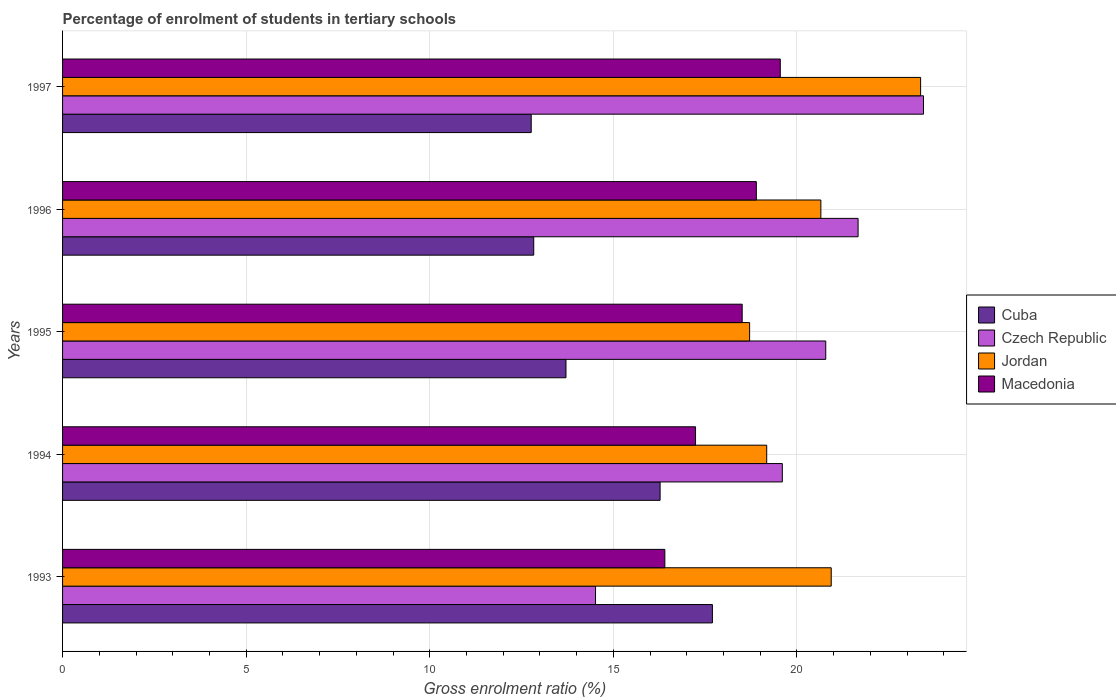How many different coloured bars are there?
Ensure brevity in your answer.  4. How many bars are there on the 1st tick from the top?
Provide a succinct answer. 4. How many bars are there on the 1st tick from the bottom?
Your answer should be very brief. 4. What is the percentage of students enrolled in tertiary schools in Cuba in 1995?
Keep it short and to the point. 13.71. Across all years, what is the maximum percentage of students enrolled in tertiary schools in Czech Republic?
Offer a very short reply. 23.45. Across all years, what is the minimum percentage of students enrolled in tertiary schools in Macedonia?
Give a very brief answer. 16.4. In which year was the percentage of students enrolled in tertiary schools in Czech Republic maximum?
Provide a short and direct response. 1997. What is the total percentage of students enrolled in tertiary schools in Cuba in the graph?
Keep it short and to the point. 73.28. What is the difference between the percentage of students enrolled in tertiary schools in Czech Republic in 1993 and that in 1995?
Provide a succinct answer. -6.27. What is the difference between the percentage of students enrolled in tertiary schools in Czech Republic in 1996 and the percentage of students enrolled in tertiary schools in Jordan in 1997?
Provide a succinct answer. -1.7. What is the average percentage of students enrolled in tertiary schools in Czech Republic per year?
Keep it short and to the point. 20. In the year 1995, what is the difference between the percentage of students enrolled in tertiary schools in Cuba and percentage of students enrolled in tertiary schools in Czech Republic?
Keep it short and to the point. -7.07. In how many years, is the percentage of students enrolled in tertiary schools in Macedonia greater than 2 %?
Offer a terse response. 5. What is the ratio of the percentage of students enrolled in tertiary schools in Macedonia in 1995 to that in 1997?
Provide a short and direct response. 0.95. Is the difference between the percentage of students enrolled in tertiary schools in Cuba in 1993 and 1994 greater than the difference between the percentage of students enrolled in tertiary schools in Czech Republic in 1993 and 1994?
Offer a terse response. Yes. What is the difference between the highest and the second highest percentage of students enrolled in tertiary schools in Cuba?
Make the answer very short. 1.42. What is the difference between the highest and the lowest percentage of students enrolled in tertiary schools in Czech Republic?
Offer a terse response. 8.93. In how many years, is the percentage of students enrolled in tertiary schools in Jordan greater than the average percentage of students enrolled in tertiary schools in Jordan taken over all years?
Ensure brevity in your answer.  3. What does the 3rd bar from the top in 1997 represents?
Your answer should be very brief. Czech Republic. What does the 1st bar from the bottom in 1997 represents?
Make the answer very short. Cuba. Is it the case that in every year, the sum of the percentage of students enrolled in tertiary schools in Cuba and percentage of students enrolled in tertiary schools in Jordan is greater than the percentage of students enrolled in tertiary schools in Macedonia?
Offer a very short reply. Yes. Are all the bars in the graph horizontal?
Your answer should be compact. Yes. How many years are there in the graph?
Provide a short and direct response. 5. Are the values on the major ticks of X-axis written in scientific E-notation?
Ensure brevity in your answer.  No. Does the graph contain any zero values?
Offer a very short reply. No. Does the graph contain grids?
Offer a very short reply. Yes. Where does the legend appear in the graph?
Provide a short and direct response. Center right. How are the legend labels stacked?
Keep it short and to the point. Vertical. What is the title of the graph?
Your answer should be very brief. Percentage of enrolment of students in tertiary schools. What is the Gross enrolment ratio (%) in Cuba in 1993?
Your answer should be very brief. 17.7. What is the Gross enrolment ratio (%) in Czech Republic in 1993?
Your answer should be compact. 14.52. What is the Gross enrolment ratio (%) of Jordan in 1993?
Keep it short and to the point. 20.93. What is the Gross enrolment ratio (%) of Macedonia in 1993?
Your answer should be very brief. 16.4. What is the Gross enrolment ratio (%) in Cuba in 1994?
Provide a succinct answer. 16.27. What is the Gross enrolment ratio (%) in Czech Republic in 1994?
Make the answer very short. 19.6. What is the Gross enrolment ratio (%) in Jordan in 1994?
Provide a succinct answer. 19.18. What is the Gross enrolment ratio (%) of Macedonia in 1994?
Give a very brief answer. 17.24. What is the Gross enrolment ratio (%) of Cuba in 1995?
Keep it short and to the point. 13.71. What is the Gross enrolment ratio (%) in Czech Republic in 1995?
Offer a terse response. 20.79. What is the Gross enrolment ratio (%) of Jordan in 1995?
Provide a short and direct response. 18.71. What is the Gross enrolment ratio (%) in Macedonia in 1995?
Make the answer very short. 18.51. What is the Gross enrolment ratio (%) in Cuba in 1996?
Provide a short and direct response. 12.83. What is the Gross enrolment ratio (%) of Czech Republic in 1996?
Make the answer very short. 21.67. What is the Gross enrolment ratio (%) of Jordan in 1996?
Provide a succinct answer. 20.65. What is the Gross enrolment ratio (%) of Macedonia in 1996?
Your answer should be compact. 18.9. What is the Gross enrolment ratio (%) in Cuba in 1997?
Give a very brief answer. 12.76. What is the Gross enrolment ratio (%) in Czech Republic in 1997?
Your answer should be compact. 23.45. What is the Gross enrolment ratio (%) in Jordan in 1997?
Give a very brief answer. 23.37. What is the Gross enrolment ratio (%) in Macedonia in 1997?
Your answer should be very brief. 19.55. Across all years, what is the maximum Gross enrolment ratio (%) in Cuba?
Provide a short and direct response. 17.7. Across all years, what is the maximum Gross enrolment ratio (%) of Czech Republic?
Offer a very short reply. 23.45. Across all years, what is the maximum Gross enrolment ratio (%) in Jordan?
Make the answer very short. 23.37. Across all years, what is the maximum Gross enrolment ratio (%) in Macedonia?
Offer a very short reply. 19.55. Across all years, what is the minimum Gross enrolment ratio (%) of Cuba?
Give a very brief answer. 12.76. Across all years, what is the minimum Gross enrolment ratio (%) in Czech Republic?
Your answer should be compact. 14.52. Across all years, what is the minimum Gross enrolment ratio (%) in Jordan?
Keep it short and to the point. 18.71. Across all years, what is the minimum Gross enrolment ratio (%) in Macedonia?
Offer a terse response. 16.4. What is the total Gross enrolment ratio (%) in Cuba in the graph?
Your answer should be very brief. 73.28. What is the total Gross enrolment ratio (%) of Czech Republic in the graph?
Your response must be concise. 100.02. What is the total Gross enrolment ratio (%) of Jordan in the graph?
Your answer should be compact. 102.85. What is the total Gross enrolment ratio (%) in Macedonia in the graph?
Ensure brevity in your answer.  90.6. What is the difference between the Gross enrolment ratio (%) in Cuba in 1993 and that in 1994?
Ensure brevity in your answer.  1.42. What is the difference between the Gross enrolment ratio (%) in Czech Republic in 1993 and that in 1994?
Keep it short and to the point. -5.09. What is the difference between the Gross enrolment ratio (%) in Jordan in 1993 and that in 1994?
Keep it short and to the point. 1.76. What is the difference between the Gross enrolment ratio (%) in Macedonia in 1993 and that in 1994?
Keep it short and to the point. -0.84. What is the difference between the Gross enrolment ratio (%) of Cuba in 1993 and that in 1995?
Give a very brief answer. 3.99. What is the difference between the Gross enrolment ratio (%) in Czech Republic in 1993 and that in 1995?
Your response must be concise. -6.27. What is the difference between the Gross enrolment ratio (%) of Jordan in 1993 and that in 1995?
Your answer should be compact. 2.22. What is the difference between the Gross enrolment ratio (%) of Macedonia in 1993 and that in 1995?
Your answer should be very brief. -2.11. What is the difference between the Gross enrolment ratio (%) in Cuba in 1993 and that in 1996?
Make the answer very short. 4.87. What is the difference between the Gross enrolment ratio (%) of Czech Republic in 1993 and that in 1996?
Your answer should be compact. -7.15. What is the difference between the Gross enrolment ratio (%) of Jordan in 1993 and that in 1996?
Offer a very short reply. 0.28. What is the difference between the Gross enrolment ratio (%) of Macedonia in 1993 and that in 1996?
Your answer should be compact. -2.49. What is the difference between the Gross enrolment ratio (%) of Cuba in 1993 and that in 1997?
Make the answer very short. 4.93. What is the difference between the Gross enrolment ratio (%) in Czech Republic in 1993 and that in 1997?
Your answer should be compact. -8.93. What is the difference between the Gross enrolment ratio (%) of Jordan in 1993 and that in 1997?
Offer a terse response. -2.43. What is the difference between the Gross enrolment ratio (%) of Macedonia in 1993 and that in 1997?
Offer a terse response. -3.14. What is the difference between the Gross enrolment ratio (%) of Cuba in 1994 and that in 1995?
Give a very brief answer. 2.56. What is the difference between the Gross enrolment ratio (%) of Czech Republic in 1994 and that in 1995?
Your answer should be very brief. -1.18. What is the difference between the Gross enrolment ratio (%) in Jordan in 1994 and that in 1995?
Your answer should be very brief. 0.47. What is the difference between the Gross enrolment ratio (%) in Macedonia in 1994 and that in 1995?
Offer a very short reply. -1.27. What is the difference between the Gross enrolment ratio (%) in Cuba in 1994 and that in 1996?
Keep it short and to the point. 3.44. What is the difference between the Gross enrolment ratio (%) of Czech Republic in 1994 and that in 1996?
Make the answer very short. -2.06. What is the difference between the Gross enrolment ratio (%) of Jordan in 1994 and that in 1996?
Your answer should be very brief. -1.48. What is the difference between the Gross enrolment ratio (%) of Macedonia in 1994 and that in 1996?
Your response must be concise. -1.66. What is the difference between the Gross enrolment ratio (%) of Cuba in 1994 and that in 1997?
Offer a very short reply. 3.51. What is the difference between the Gross enrolment ratio (%) in Czech Republic in 1994 and that in 1997?
Offer a very short reply. -3.85. What is the difference between the Gross enrolment ratio (%) of Jordan in 1994 and that in 1997?
Provide a succinct answer. -4.19. What is the difference between the Gross enrolment ratio (%) in Macedonia in 1994 and that in 1997?
Provide a short and direct response. -2.31. What is the difference between the Gross enrolment ratio (%) of Cuba in 1995 and that in 1996?
Make the answer very short. 0.88. What is the difference between the Gross enrolment ratio (%) of Czech Republic in 1995 and that in 1996?
Provide a succinct answer. -0.88. What is the difference between the Gross enrolment ratio (%) of Jordan in 1995 and that in 1996?
Make the answer very short. -1.94. What is the difference between the Gross enrolment ratio (%) in Macedonia in 1995 and that in 1996?
Make the answer very short. -0.39. What is the difference between the Gross enrolment ratio (%) of Cuba in 1995 and that in 1997?
Offer a terse response. 0.95. What is the difference between the Gross enrolment ratio (%) of Czech Republic in 1995 and that in 1997?
Your answer should be very brief. -2.66. What is the difference between the Gross enrolment ratio (%) of Jordan in 1995 and that in 1997?
Your answer should be very brief. -4.66. What is the difference between the Gross enrolment ratio (%) in Macedonia in 1995 and that in 1997?
Ensure brevity in your answer.  -1.04. What is the difference between the Gross enrolment ratio (%) in Cuba in 1996 and that in 1997?
Provide a short and direct response. 0.07. What is the difference between the Gross enrolment ratio (%) in Czech Republic in 1996 and that in 1997?
Offer a very short reply. -1.78. What is the difference between the Gross enrolment ratio (%) of Jordan in 1996 and that in 1997?
Provide a succinct answer. -2.72. What is the difference between the Gross enrolment ratio (%) of Macedonia in 1996 and that in 1997?
Your response must be concise. -0.65. What is the difference between the Gross enrolment ratio (%) of Cuba in 1993 and the Gross enrolment ratio (%) of Czech Republic in 1994?
Offer a very short reply. -1.9. What is the difference between the Gross enrolment ratio (%) in Cuba in 1993 and the Gross enrolment ratio (%) in Jordan in 1994?
Ensure brevity in your answer.  -1.48. What is the difference between the Gross enrolment ratio (%) of Cuba in 1993 and the Gross enrolment ratio (%) of Macedonia in 1994?
Ensure brevity in your answer.  0.46. What is the difference between the Gross enrolment ratio (%) of Czech Republic in 1993 and the Gross enrolment ratio (%) of Jordan in 1994?
Keep it short and to the point. -4.66. What is the difference between the Gross enrolment ratio (%) of Czech Republic in 1993 and the Gross enrolment ratio (%) of Macedonia in 1994?
Your answer should be very brief. -2.72. What is the difference between the Gross enrolment ratio (%) in Jordan in 1993 and the Gross enrolment ratio (%) in Macedonia in 1994?
Keep it short and to the point. 3.7. What is the difference between the Gross enrolment ratio (%) of Cuba in 1993 and the Gross enrolment ratio (%) of Czech Republic in 1995?
Keep it short and to the point. -3.09. What is the difference between the Gross enrolment ratio (%) in Cuba in 1993 and the Gross enrolment ratio (%) in Jordan in 1995?
Offer a very short reply. -1.01. What is the difference between the Gross enrolment ratio (%) of Cuba in 1993 and the Gross enrolment ratio (%) of Macedonia in 1995?
Provide a succinct answer. -0.81. What is the difference between the Gross enrolment ratio (%) in Czech Republic in 1993 and the Gross enrolment ratio (%) in Jordan in 1995?
Your answer should be very brief. -4.2. What is the difference between the Gross enrolment ratio (%) of Czech Republic in 1993 and the Gross enrolment ratio (%) of Macedonia in 1995?
Your response must be concise. -3.99. What is the difference between the Gross enrolment ratio (%) of Jordan in 1993 and the Gross enrolment ratio (%) of Macedonia in 1995?
Provide a short and direct response. 2.42. What is the difference between the Gross enrolment ratio (%) of Cuba in 1993 and the Gross enrolment ratio (%) of Czech Republic in 1996?
Give a very brief answer. -3.97. What is the difference between the Gross enrolment ratio (%) of Cuba in 1993 and the Gross enrolment ratio (%) of Jordan in 1996?
Keep it short and to the point. -2.95. What is the difference between the Gross enrolment ratio (%) of Cuba in 1993 and the Gross enrolment ratio (%) of Macedonia in 1996?
Provide a succinct answer. -1.2. What is the difference between the Gross enrolment ratio (%) of Czech Republic in 1993 and the Gross enrolment ratio (%) of Jordan in 1996?
Your answer should be compact. -6.14. What is the difference between the Gross enrolment ratio (%) of Czech Republic in 1993 and the Gross enrolment ratio (%) of Macedonia in 1996?
Ensure brevity in your answer.  -4.38. What is the difference between the Gross enrolment ratio (%) of Jordan in 1993 and the Gross enrolment ratio (%) of Macedonia in 1996?
Your answer should be compact. 2.04. What is the difference between the Gross enrolment ratio (%) of Cuba in 1993 and the Gross enrolment ratio (%) of Czech Republic in 1997?
Ensure brevity in your answer.  -5.75. What is the difference between the Gross enrolment ratio (%) in Cuba in 1993 and the Gross enrolment ratio (%) in Jordan in 1997?
Your response must be concise. -5.67. What is the difference between the Gross enrolment ratio (%) in Cuba in 1993 and the Gross enrolment ratio (%) in Macedonia in 1997?
Give a very brief answer. -1.85. What is the difference between the Gross enrolment ratio (%) of Czech Republic in 1993 and the Gross enrolment ratio (%) of Jordan in 1997?
Your answer should be compact. -8.85. What is the difference between the Gross enrolment ratio (%) in Czech Republic in 1993 and the Gross enrolment ratio (%) in Macedonia in 1997?
Your answer should be compact. -5.03. What is the difference between the Gross enrolment ratio (%) of Jordan in 1993 and the Gross enrolment ratio (%) of Macedonia in 1997?
Make the answer very short. 1.39. What is the difference between the Gross enrolment ratio (%) in Cuba in 1994 and the Gross enrolment ratio (%) in Czech Republic in 1995?
Offer a terse response. -4.51. What is the difference between the Gross enrolment ratio (%) in Cuba in 1994 and the Gross enrolment ratio (%) in Jordan in 1995?
Offer a terse response. -2.44. What is the difference between the Gross enrolment ratio (%) in Cuba in 1994 and the Gross enrolment ratio (%) in Macedonia in 1995?
Provide a succinct answer. -2.24. What is the difference between the Gross enrolment ratio (%) of Czech Republic in 1994 and the Gross enrolment ratio (%) of Jordan in 1995?
Give a very brief answer. 0.89. What is the difference between the Gross enrolment ratio (%) in Czech Republic in 1994 and the Gross enrolment ratio (%) in Macedonia in 1995?
Make the answer very short. 1.09. What is the difference between the Gross enrolment ratio (%) of Jordan in 1994 and the Gross enrolment ratio (%) of Macedonia in 1995?
Offer a terse response. 0.67. What is the difference between the Gross enrolment ratio (%) of Cuba in 1994 and the Gross enrolment ratio (%) of Czech Republic in 1996?
Offer a very short reply. -5.39. What is the difference between the Gross enrolment ratio (%) of Cuba in 1994 and the Gross enrolment ratio (%) of Jordan in 1996?
Offer a very short reply. -4.38. What is the difference between the Gross enrolment ratio (%) of Cuba in 1994 and the Gross enrolment ratio (%) of Macedonia in 1996?
Provide a short and direct response. -2.62. What is the difference between the Gross enrolment ratio (%) of Czech Republic in 1994 and the Gross enrolment ratio (%) of Jordan in 1996?
Offer a very short reply. -1.05. What is the difference between the Gross enrolment ratio (%) in Czech Republic in 1994 and the Gross enrolment ratio (%) in Macedonia in 1996?
Ensure brevity in your answer.  0.71. What is the difference between the Gross enrolment ratio (%) of Jordan in 1994 and the Gross enrolment ratio (%) of Macedonia in 1996?
Keep it short and to the point. 0.28. What is the difference between the Gross enrolment ratio (%) in Cuba in 1994 and the Gross enrolment ratio (%) in Czech Republic in 1997?
Ensure brevity in your answer.  -7.17. What is the difference between the Gross enrolment ratio (%) of Cuba in 1994 and the Gross enrolment ratio (%) of Jordan in 1997?
Provide a succinct answer. -7.09. What is the difference between the Gross enrolment ratio (%) in Cuba in 1994 and the Gross enrolment ratio (%) in Macedonia in 1997?
Your answer should be very brief. -3.27. What is the difference between the Gross enrolment ratio (%) in Czech Republic in 1994 and the Gross enrolment ratio (%) in Jordan in 1997?
Provide a succinct answer. -3.77. What is the difference between the Gross enrolment ratio (%) in Czech Republic in 1994 and the Gross enrolment ratio (%) in Macedonia in 1997?
Provide a short and direct response. 0.06. What is the difference between the Gross enrolment ratio (%) in Jordan in 1994 and the Gross enrolment ratio (%) in Macedonia in 1997?
Give a very brief answer. -0.37. What is the difference between the Gross enrolment ratio (%) of Cuba in 1995 and the Gross enrolment ratio (%) of Czech Republic in 1996?
Keep it short and to the point. -7.96. What is the difference between the Gross enrolment ratio (%) in Cuba in 1995 and the Gross enrolment ratio (%) in Jordan in 1996?
Provide a succinct answer. -6.94. What is the difference between the Gross enrolment ratio (%) in Cuba in 1995 and the Gross enrolment ratio (%) in Macedonia in 1996?
Provide a succinct answer. -5.18. What is the difference between the Gross enrolment ratio (%) of Czech Republic in 1995 and the Gross enrolment ratio (%) of Jordan in 1996?
Offer a very short reply. 0.13. What is the difference between the Gross enrolment ratio (%) of Czech Republic in 1995 and the Gross enrolment ratio (%) of Macedonia in 1996?
Provide a succinct answer. 1.89. What is the difference between the Gross enrolment ratio (%) of Jordan in 1995 and the Gross enrolment ratio (%) of Macedonia in 1996?
Provide a succinct answer. -0.18. What is the difference between the Gross enrolment ratio (%) of Cuba in 1995 and the Gross enrolment ratio (%) of Czech Republic in 1997?
Offer a very short reply. -9.74. What is the difference between the Gross enrolment ratio (%) of Cuba in 1995 and the Gross enrolment ratio (%) of Jordan in 1997?
Offer a very short reply. -9.66. What is the difference between the Gross enrolment ratio (%) of Cuba in 1995 and the Gross enrolment ratio (%) of Macedonia in 1997?
Your answer should be compact. -5.84. What is the difference between the Gross enrolment ratio (%) in Czech Republic in 1995 and the Gross enrolment ratio (%) in Jordan in 1997?
Make the answer very short. -2.58. What is the difference between the Gross enrolment ratio (%) of Czech Republic in 1995 and the Gross enrolment ratio (%) of Macedonia in 1997?
Your answer should be compact. 1.24. What is the difference between the Gross enrolment ratio (%) in Jordan in 1995 and the Gross enrolment ratio (%) in Macedonia in 1997?
Make the answer very short. -0.84. What is the difference between the Gross enrolment ratio (%) in Cuba in 1996 and the Gross enrolment ratio (%) in Czech Republic in 1997?
Keep it short and to the point. -10.62. What is the difference between the Gross enrolment ratio (%) in Cuba in 1996 and the Gross enrolment ratio (%) in Jordan in 1997?
Give a very brief answer. -10.54. What is the difference between the Gross enrolment ratio (%) of Cuba in 1996 and the Gross enrolment ratio (%) of Macedonia in 1997?
Your answer should be compact. -6.71. What is the difference between the Gross enrolment ratio (%) of Czech Republic in 1996 and the Gross enrolment ratio (%) of Jordan in 1997?
Provide a short and direct response. -1.7. What is the difference between the Gross enrolment ratio (%) of Czech Republic in 1996 and the Gross enrolment ratio (%) of Macedonia in 1997?
Offer a very short reply. 2.12. What is the difference between the Gross enrolment ratio (%) in Jordan in 1996 and the Gross enrolment ratio (%) in Macedonia in 1997?
Your answer should be very brief. 1.11. What is the average Gross enrolment ratio (%) of Cuba per year?
Your answer should be compact. 14.66. What is the average Gross enrolment ratio (%) in Czech Republic per year?
Your response must be concise. 20. What is the average Gross enrolment ratio (%) of Jordan per year?
Make the answer very short. 20.57. What is the average Gross enrolment ratio (%) of Macedonia per year?
Your response must be concise. 18.12. In the year 1993, what is the difference between the Gross enrolment ratio (%) of Cuba and Gross enrolment ratio (%) of Czech Republic?
Offer a terse response. 3.18. In the year 1993, what is the difference between the Gross enrolment ratio (%) of Cuba and Gross enrolment ratio (%) of Jordan?
Offer a very short reply. -3.24. In the year 1993, what is the difference between the Gross enrolment ratio (%) in Cuba and Gross enrolment ratio (%) in Macedonia?
Your response must be concise. 1.3. In the year 1993, what is the difference between the Gross enrolment ratio (%) of Czech Republic and Gross enrolment ratio (%) of Jordan?
Your response must be concise. -6.42. In the year 1993, what is the difference between the Gross enrolment ratio (%) in Czech Republic and Gross enrolment ratio (%) in Macedonia?
Keep it short and to the point. -1.89. In the year 1993, what is the difference between the Gross enrolment ratio (%) in Jordan and Gross enrolment ratio (%) in Macedonia?
Ensure brevity in your answer.  4.53. In the year 1994, what is the difference between the Gross enrolment ratio (%) in Cuba and Gross enrolment ratio (%) in Czech Republic?
Provide a short and direct response. -3.33. In the year 1994, what is the difference between the Gross enrolment ratio (%) in Cuba and Gross enrolment ratio (%) in Jordan?
Your answer should be compact. -2.9. In the year 1994, what is the difference between the Gross enrolment ratio (%) in Cuba and Gross enrolment ratio (%) in Macedonia?
Your answer should be very brief. -0.96. In the year 1994, what is the difference between the Gross enrolment ratio (%) of Czech Republic and Gross enrolment ratio (%) of Jordan?
Offer a very short reply. 0.43. In the year 1994, what is the difference between the Gross enrolment ratio (%) of Czech Republic and Gross enrolment ratio (%) of Macedonia?
Ensure brevity in your answer.  2.36. In the year 1994, what is the difference between the Gross enrolment ratio (%) in Jordan and Gross enrolment ratio (%) in Macedonia?
Your response must be concise. 1.94. In the year 1995, what is the difference between the Gross enrolment ratio (%) in Cuba and Gross enrolment ratio (%) in Czech Republic?
Your response must be concise. -7.07. In the year 1995, what is the difference between the Gross enrolment ratio (%) in Cuba and Gross enrolment ratio (%) in Jordan?
Your answer should be compact. -5. In the year 1995, what is the difference between the Gross enrolment ratio (%) of Cuba and Gross enrolment ratio (%) of Macedonia?
Offer a terse response. -4.8. In the year 1995, what is the difference between the Gross enrolment ratio (%) of Czech Republic and Gross enrolment ratio (%) of Jordan?
Make the answer very short. 2.07. In the year 1995, what is the difference between the Gross enrolment ratio (%) in Czech Republic and Gross enrolment ratio (%) in Macedonia?
Give a very brief answer. 2.28. In the year 1995, what is the difference between the Gross enrolment ratio (%) of Jordan and Gross enrolment ratio (%) of Macedonia?
Ensure brevity in your answer.  0.2. In the year 1996, what is the difference between the Gross enrolment ratio (%) in Cuba and Gross enrolment ratio (%) in Czech Republic?
Give a very brief answer. -8.83. In the year 1996, what is the difference between the Gross enrolment ratio (%) of Cuba and Gross enrolment ratio (%) of Jordan?
Give a very brief answer. -7.82. In the year 1996, what is the difference between the Gross enrolment ratio (%) in Cuba and Gross enrolment ratio (%) in Macedonia?
Your answer should be compact. -6.06. In the year 1996, what is the difference between the Gross enrolment ratio (%) of Czech Republic and Gross enrolment ratio (%) of Jordan?
Keep it short and to the point. 1.01. In the year 1996, what is the difference between the Gross enrolment ratio (%) of Czech Republic and Gross enrolment ratio (%) of Macedonia?
Your answer should be very brief. 2.77. In the year 1996, what is the difference between the Gross enrolment ratio (%) of Jordan and Gross enrolment ratio (%) of Macedonia?
Offer a very short reply. 1.76. In the year 1997, what is the difference between the Gross enrolment ratio (%) in Cuba and Gross enrolment ratio (%) in Czech Republic?
Ensure brevity in your answer.  -10.68. In the year 1997, what is the difference between the Gross enrolment ratio (%) in Cuba and Gross enrolment ratio (%) in Jordan?
Provide a short and direct response. -10.6. In the year 1997, what is the difference between the Gross enrolment ratio (%) in Cuba and Gross enrolment ratio (%) in Macedonia?
Offer a very short reply. -6.78. In the year 1997, what is the difference between the Gross enrolment ratio (%) in Czech Republic and Gross enrolment ratio (%) in Jordan?
Your response must be concise. 0.08. In the year 1997, what is the difference between the Gross enrolment ratio (%) of Czech Republic and Gross enrolment ratio (%) of Macedonia?
Offer a terse response. 3.9. In the year 1997, what is the difference between the Gross enrolment ratio (%) of Jordan and Gross enrolment ratio (%) of Macedonia?
Provide a short and direct response. 3.82. What is the ratio of the Gross enrolment ratio (%) of Cuba in 1993 to that in 1994?
Provide a succinct answer. 1.09. What is the ratio of the Gross enrolment ratio (%) in Czech Republic in 1993 to that in 1994?
Give a very brief answer. 0.74. What is the ratio of the Gross enrolment ratio (%) in Jordan in 1993 to that in 1994?
Your response must be concise. 1.09. What is the ratio of the Gross enrolment ratio (%) of Macedonia in 1993 to that in 1994?
Provide a succinct answer. 0.95. What is the ratio of the Gross enrolment ratio (%) of Cuba in 1993 to that in 1995?
Your answer should be compact. 1.29. What is the ratio of the Gross enrolment ratio (%) of Czech Republic in 1993 to that in 1995?
Give a very brief answer. 0.7. What is the ratio of the Gross enrolment ratio (%) in Jordan in 1993 to that in 1995?
Make the answer very short. 1.12. What is the ratio of the Gross enrolment ratio (%) in Macedonia in 1993 to that in 1995?
Give a very brief answer. 0.89. What is the ratio of the Gross enrolment ratio (%) in Cuba in 1993 to that in 1996?
Ensure brevity in your answer.  1.38. What is the ratio of the Gross enrolment ratio (%) of Czech Republic in 1993 to that in 1996?
Offer a very short reply. 0.67. What is the ratio of the Gross enrolment ratio (%) in Jordan in 1993 to that in 1996?
Your answer should be very brief. 1.01. What is the ratio of the Gross enrolment ratio (%) of Macedonia in 1993 to that in 1996?
Offer a terse response. 0.87. What is the ratio of the Gross enrolment ratio (%) of Cuba in 1993 to that in 1997?
Keep it short and to the point. 1.39. What is the ratio of the Gross enrolment ratio (%) of Czech Republic in 1993 to that in 1997?
Ensure brevity in your answer.  0.62. What is the ratio of the Gross enrolment ratio (%) of Jordan in 1993 to that in 1997?
Provide a short and direct response. 0.9. What is the ratio of the Gross enrolment ratio (%) in Macedonia in 1993 to that in 1997?
Your answer should be compact. 0.84. What is the ratio of the Gross enrolment ratio (%) of Cuba in 1994 to that in 1995?
Keep it short and to the point. 1.19. What is the ratio of the Gross enrolment ratio (%) of Czech Republic in 1994 to that in 1995?
Make the answer very short. 0.94. What is the ratio of the Gross enrolment ratio (%) of Jordan in 1994 to that in 1995?
Provide a succinct answer. 1.02. What is the ratio of the Gross enrolment ratio (%) of Macedonia in 1994 to that in 1995?
Ensure brevity in your answer.  0.93. What is the ratio of the Gross enrolment ratio (%) in Cuba in 1994 to that in 1996?
Keep it short and to the point. 1.27. What is the ratio of the Gross enrolment ratio (%) in Czech Republic in 1994 to that in 1996?
Offer a very short reply. 0.9. What is the ratio of the Gross enrolment ratio (%) in Jordan in 1994 to that in 1996?
Provide a succinct answer. 0.93. What is the ratio of the Gross enrolment ratio (%) in Macedonia in 1994 to that in 1996?
Make the answer very short. 0.91. What is the ratio of the Gross enrolment ratio (%) in Cuba in 1994 to that in 1997?
Keep it short and to the point. 1.27. What is the ratio of the Gross enrolment ratio (%) in Czech Republic in 1994 to that in 1997?
Ensure brevity in your answer.  0.84. What is the ratio of the Gross enrolment ratio (%) of Jordan in 1994 to that in 1997?
Offer a terse response. 0.82. What is the ratio of the Gross enrolment ratio (%) in Macedonia in 1994 to that in 1997?
Your response must be concise. 0.88. What is the ratio of the Gross enrolment ratio (%) of Cuba in 1995 to that in 1996?
Your answer should be very brief. 1.07. What is the ratio of the Gross enrolment ratio (%) in Czech Republic in 1995 to that in 1996?
Keep it short and to the point. 0.96. What is the ratio of the Gross enrolment ratio (%) in Jordan in 1995 to that in 1996?
Provide a succinct answer. 0.91. What is the ratio of the Gross enrolment ratio (%) of Macedonia in 1995 to that in 1996?
Offer a terse response. 0.98. What is the ratio of the Gross enrolment ratio (%) in Cuba in 1995 to that in 1997?
Provide a succinct answer. 1.07. What is the ratio of the Gross enrolment ratio (%) of Czech Republic in 1995 to that in 1997?
Your answer should be compact. 0.89. What is the ratio of the Gross enrolment ratio (%) in Jordan in 1995 to that in 1997?
Your answer should be very brief. 0.8. What is the ratio of the Gross enrolment ratio (%) in Macedonia in 1995 to that in 1997?
Offer a very short reply. 0.95. What is the ratio of the Gross enrolment ratio (%) of Cuba in 1996 to that in 1997?
Keep it short and to the point. 1.01. What is the ratio of the Gross enrolment ratio (%) of Czech Republic in 1996 to that in 1997?
Make the answer very short. 0.92. What is the ratio of the Gross enrolment ratio (%) of Jordan in 1996 to that in 1997?
Your response must be concise. 0.88. What is the ratio of the Gross enrolment ratio (%) in Macedonia in 1996 to that in 1997?
Keep it short and to the point. 0.97. What is the difference between the highest and the second highest Gross enrolment ratio (%) in Cuba?
Make the answer very short. 1.42. What is the difference between the highest and the second highest Gross enrolment ratio (%) of Czech Republic?
Make the answer very short. 1.78. What is the difference between the highest and the second highest Gross enrolment ratio (%) in Jordan?
Offer a very short reply. 2.43. What is the difference between the highest and the second highest Gross enrolment ratio (%) of Macedonia?
Your response must be concise. 0.65. What is the difference between the highest and the lowest Gross enrolment ratio (%) in Cuba?
Ensure brevity in your answer.  4.93. What is the difference between the highest and the lowest Gross enrolment ratio (%) in Czech Republic?
Ensure brevity in your answer.  8.93. What is the difference between the highest and the lowest Gross enrolment ratio (%) in Jordan?
Your answer should be very brief. 4.66. What is the difference between the highest and the lowest Gross enrolment ratio (%) of Macedonia?
Your answer should be very brief. 3.14. 